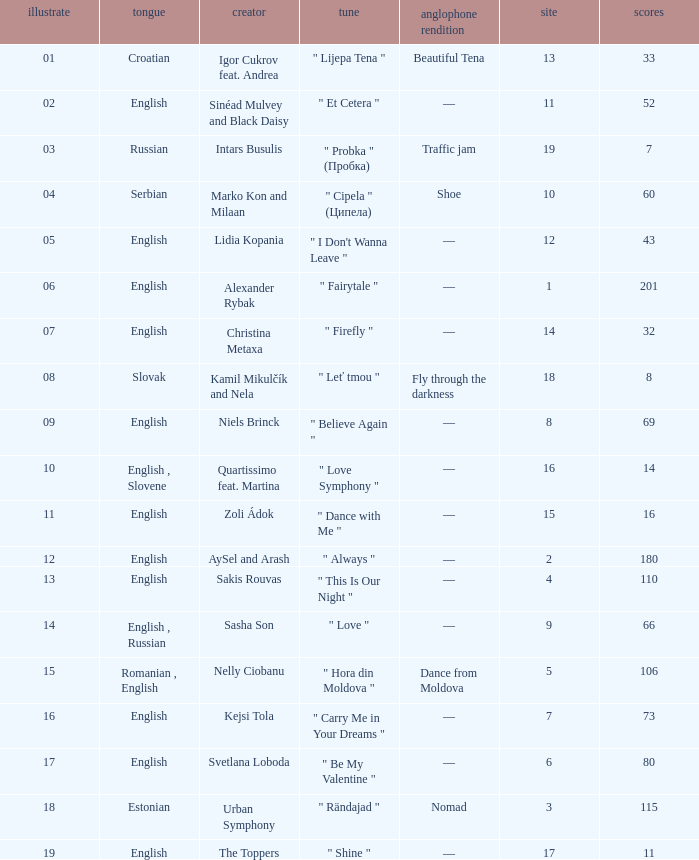What is the english translation when the language is english, draw is smaller than 16, and the artist is aysel and arash? —. 